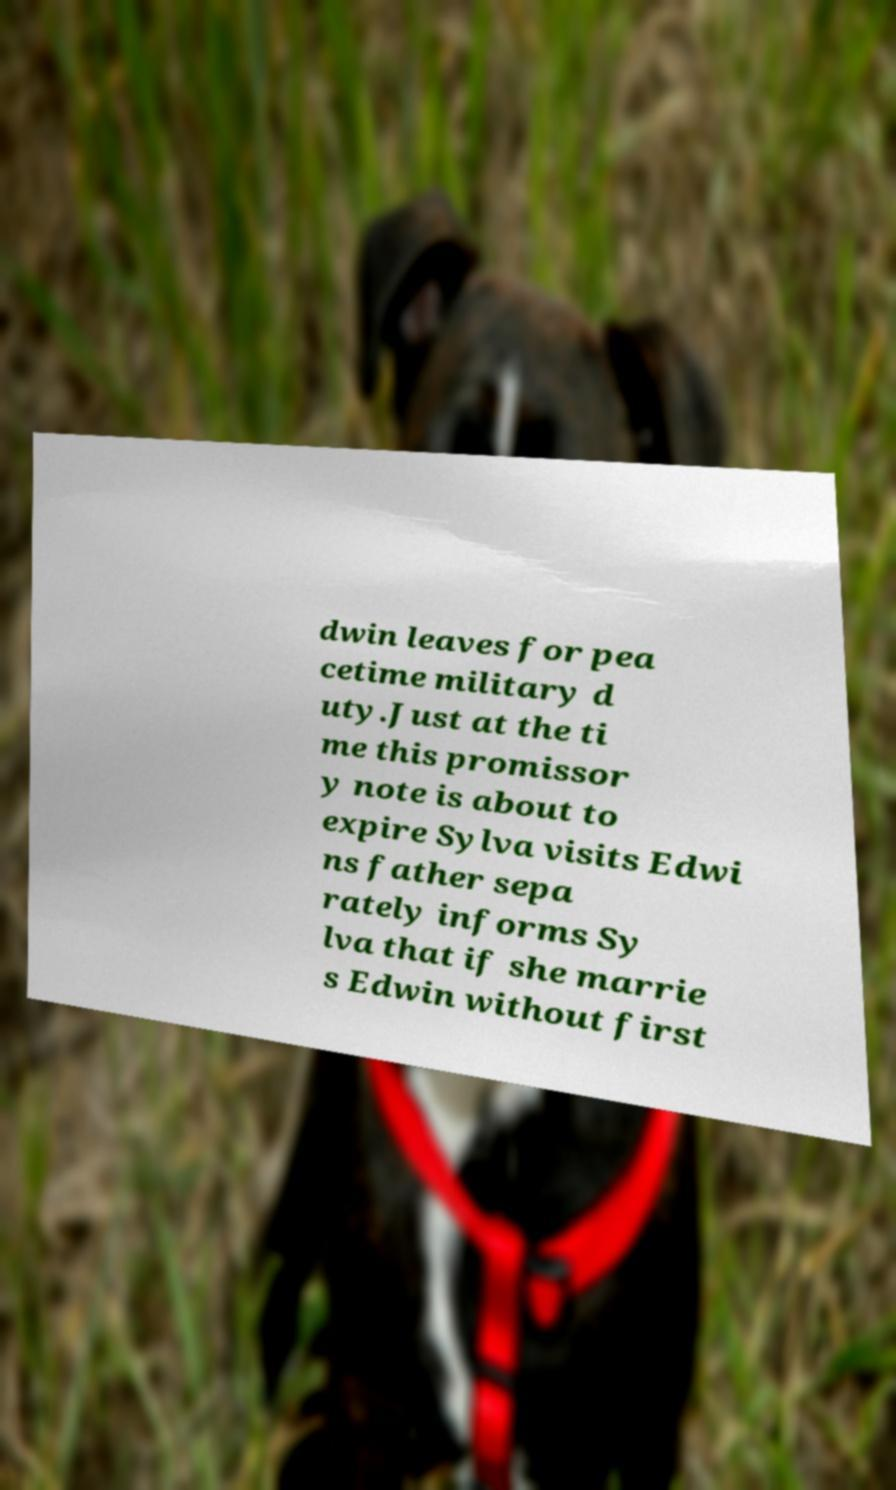What messages or text are displayed in this image? I need them in a readable, typed format. dwin leaves for pea cetime military d uty.Just at the ti me this promissor y note is about to expire Sylva visits Edwi ns father sepa rately informs Sy lva that if she marrie s Edwin without first 